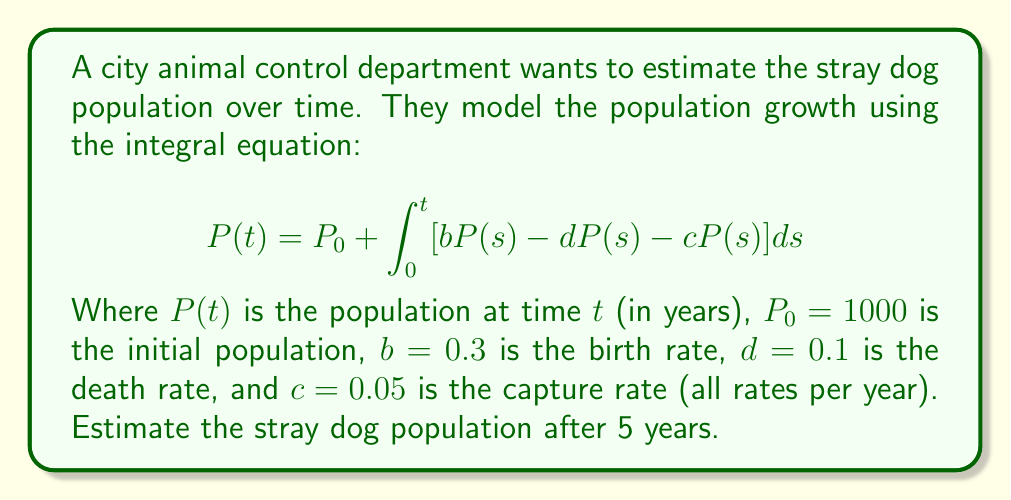What is the answer to this math problem? Let's approach this step-by-step:

1) First, we need to simplify the integrand:
   $bP(s) - dP(s) - cP(s) = (b-d-c)P(s) = (0.3-0.1-0.05)P(s) = 0.15P(s)$

2) Now our equation looks like this:
   $$P(t) = 1000 + \int_0^t 0.15P(s)ds$$

3) This is a linear integral equation. The solution has the form:
   $$P(t) = 1000e^{0.15t}$$

4) We can verify this by substituting it back into the original equation:
   $$1000e^{0.15t} = 1000 + \int_0^t 0.15(1000e^{0.15s})ds$$
   $$1000e^{0.15t} = 1000 + 1000[e^{0.15s}]_0^t = 1000 + 1000(e^{0.15t} - 1)$$
   $$1000e^{0.15t} = 1000e^{0.15t}$$

5) Now that we have the solution, we can estimate the population after 5 years:
   $$P(5) = 1000e^{0.15(5)} = 1000e^{0.75} \approx 2117$$

Therefore, after 5 years, the estimated stray dog population is approximately 2117 dogs.
Answer: 2117 dogs 